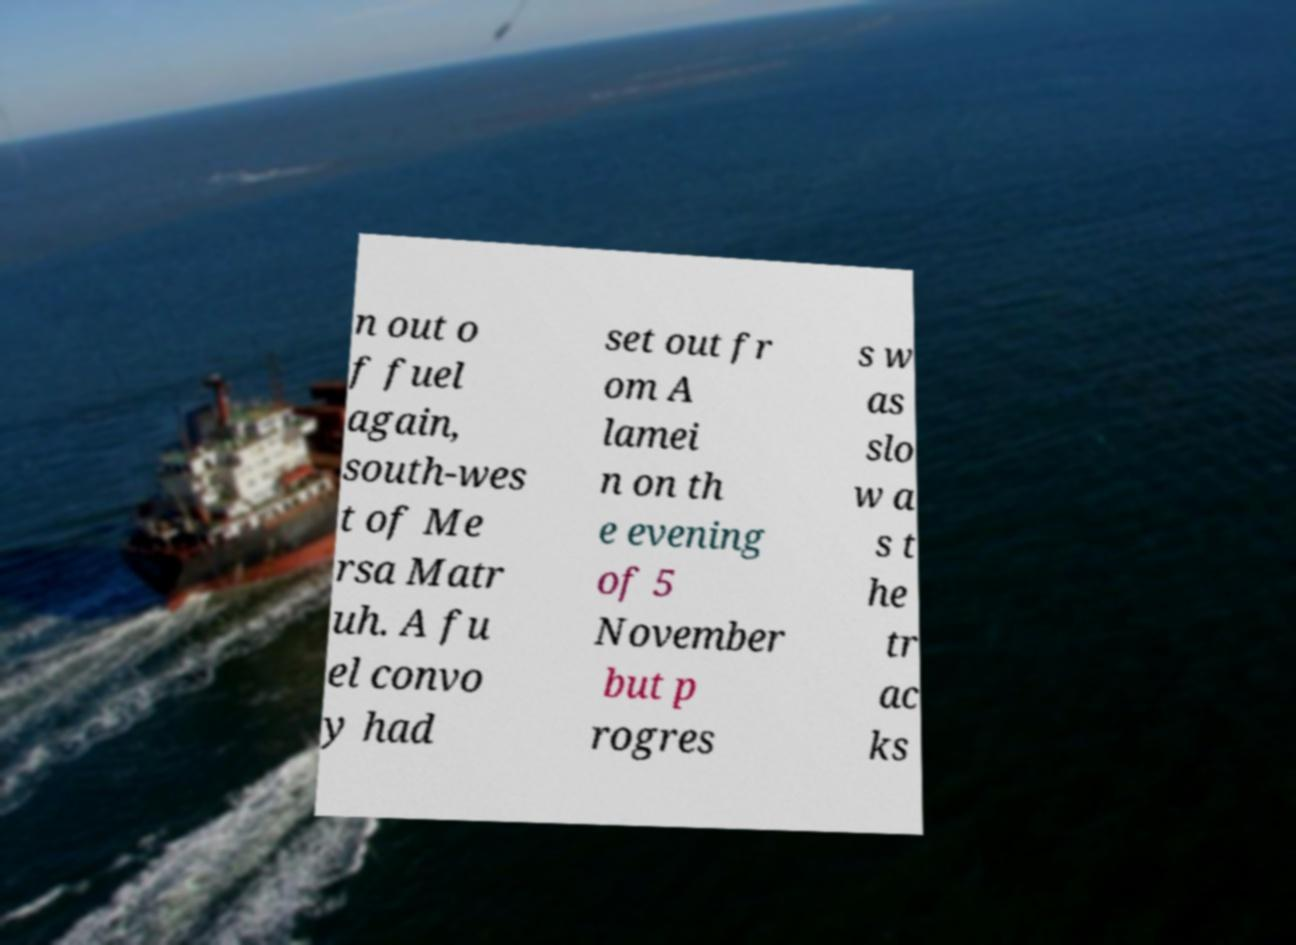Can you accurately transcribe the text from the provided image for me? n out o f fuel again, south-wes t of Me rsa Matr uh. A fu el convo y had set out fr om A lamei n on th e evening of 5 November but p rogres s w as slo w a s t he tr ac ks 